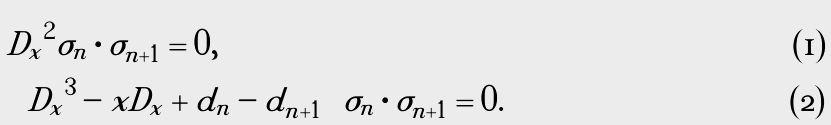Convert formula to latex. <formula><loc_0><loc_0><loc_500><loc_500>& { D _ { x } } ^ { 2 } \sigma _ { n } \cdot \sigma _ { n + 1 } = 0 , \\ & \left ( { D _ { x } } ^ { 3 } - x D _ { x } + d _ { n } - d _ { n + 1 } \right ) \sigma _ { n } \cdot \sigma _ { n + 1 } = 0 .</formula> 